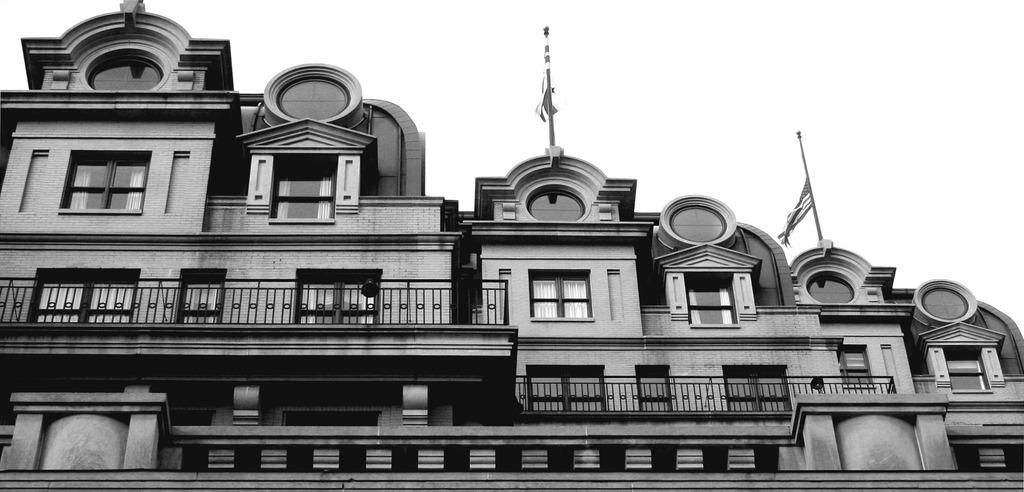What structure is present in the image? There is a building in the image. What feature can be observed on the building? The building has windows. What other objects are visible in the image? There are poles and flags in the image. Where is the garden located in the image? There is no garden present in the image. What type of fruit is hanging from the poles in the image? There is no fruit, specifically quince, hanging from the poles in the image. 